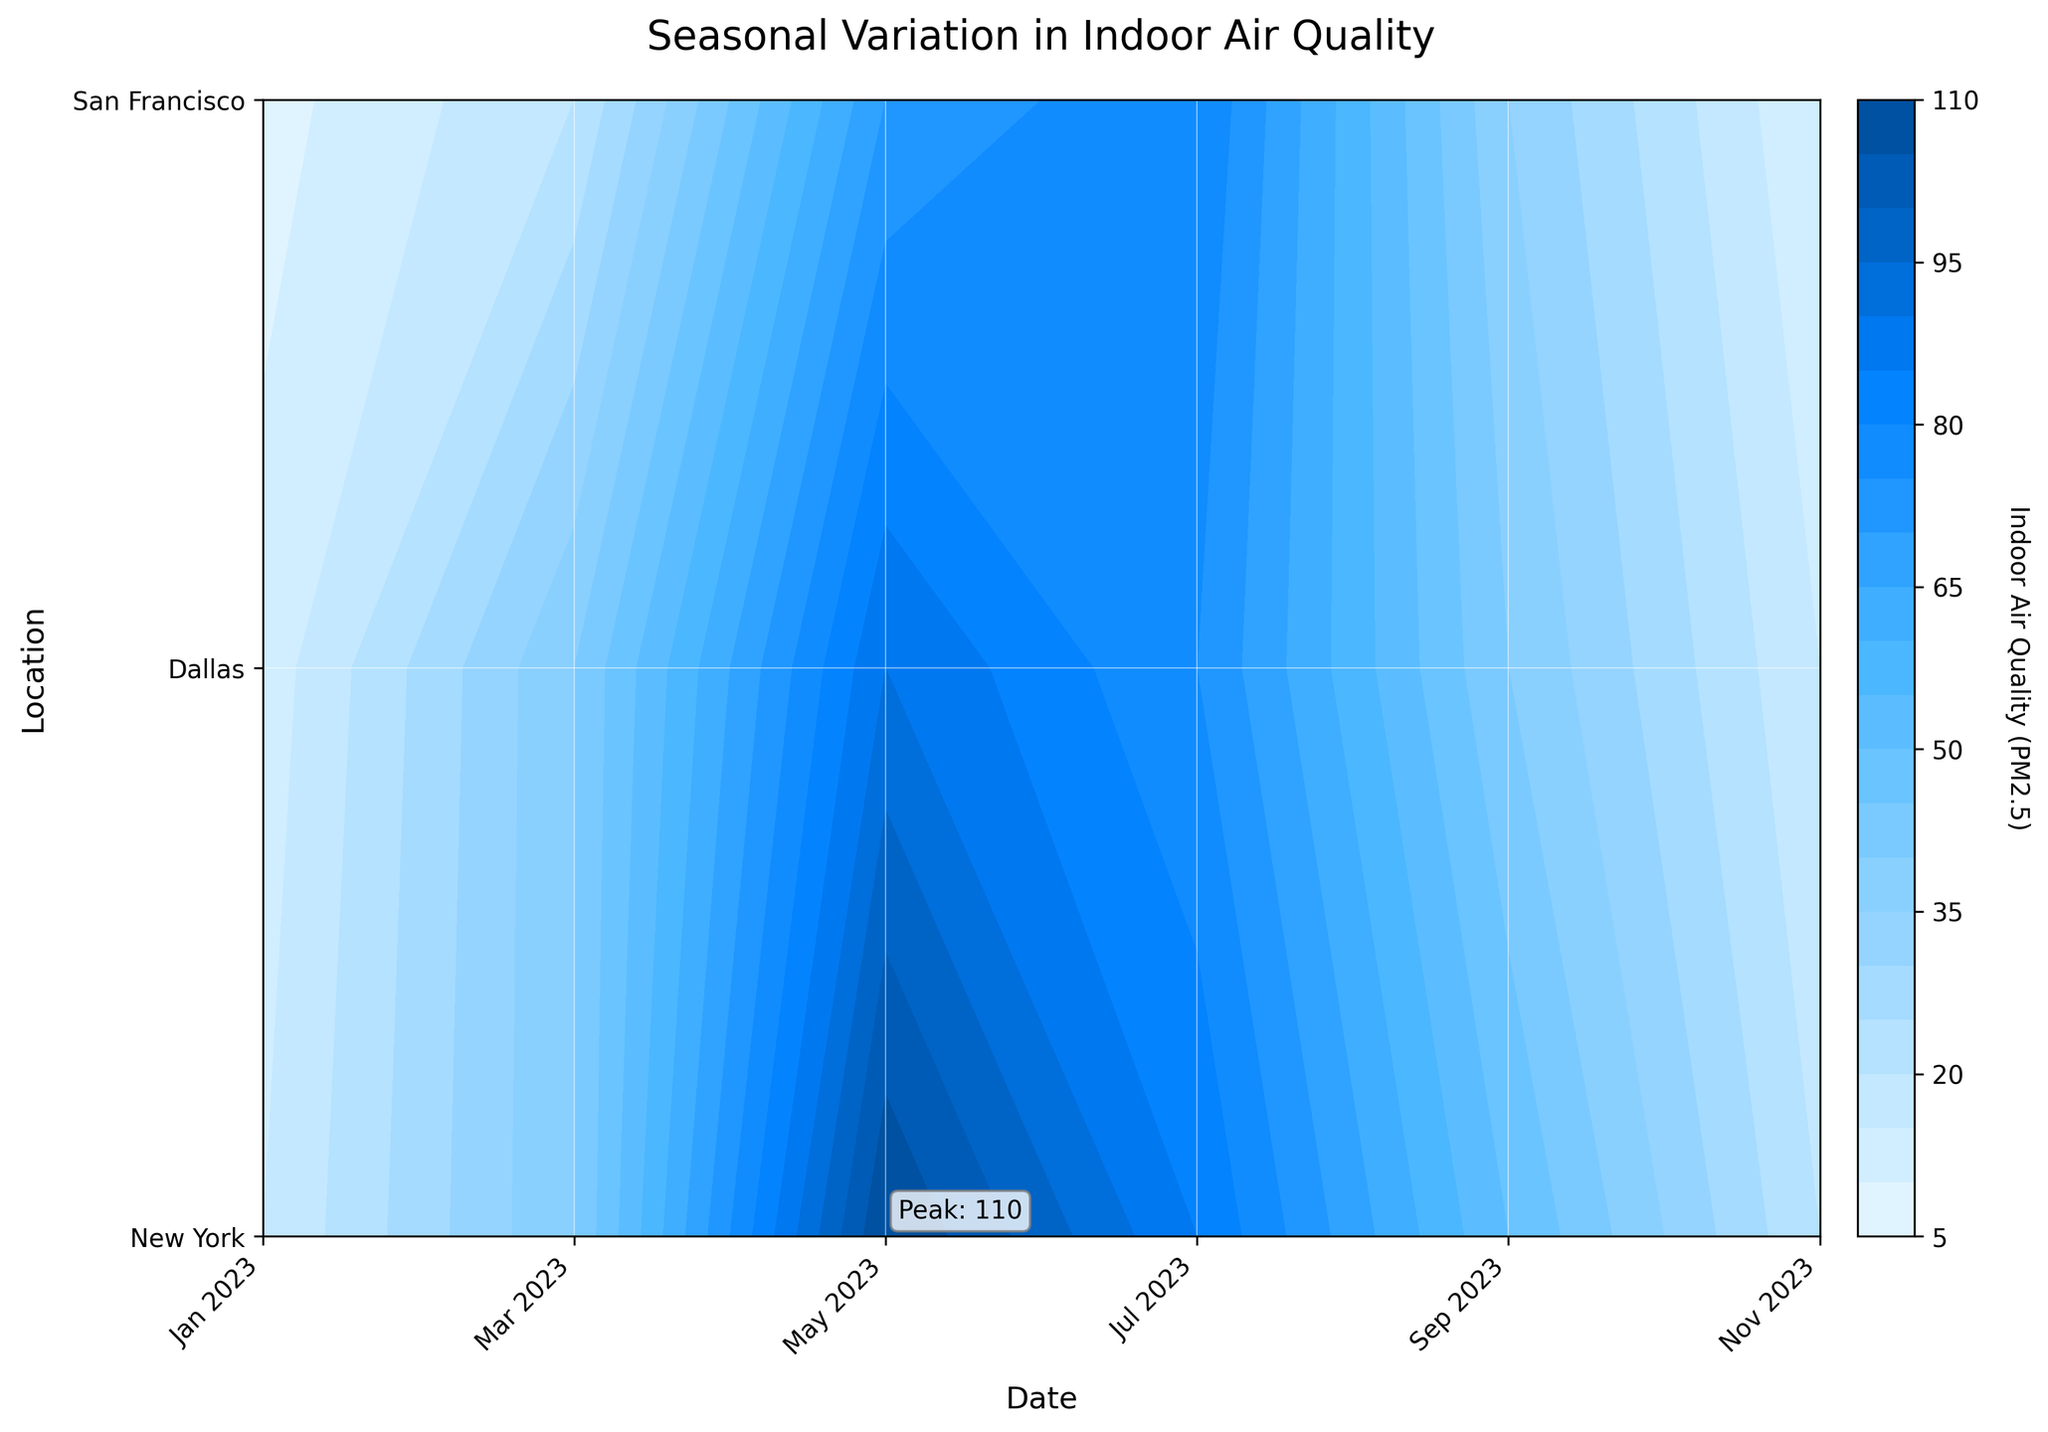What is the title of the plot? The title is usually placed at the top of the plot. In this case, it's written in the figure.
Answer: Seasonal Variation in Indoor Air Quality Which month shows the peak indoor air quality (PM2.5) values? The figure annotates the peak value with the word "Peak". By looking at this annotation, the peak value occurs in May.
Answer: May How does the indoor air quality (PM2.5) in Dallas change from January to July? From January to July in Dallas, the indoor air quality (PM2.5) can be traced from the left to the right across the y-axis label "Dallas" and observing the contour levels: it increases from 15 in January, 40 in March, 110 in May, and reaching 85 in July.
Answer: It increases from January to May, then slightly decreases by July Which location exhibits the highest indoor air quality (PM2.5) in September? In September, by following the x-axis label representing September, San Francisco shows the lowest indoor air quality value (35), compared to New York (40) and Dallas (50).
Answer: Dallas Is the indoor air quality (PM2.5) worse during the summer or winter months in New York? By comparing contour levels across seasons in New York: summer months (July, with a value of 75) show higher values than winter months (January, with a value of 12) indicating worse air quality during summer.
Answer: Summer Compare indoor air quality (PM2.5) levels between New York and San Francisco in March. Which city has better air quality? Trace the March data vertically for both cities, touching the y-axis labels. New York has a level of 40, and San Francisco has a level of 20.
Answer: San Francisco During which month is indoor air quality (PM2.5) in New York the worst? Follow the New York row and identify the month with the highest contour level. May has the highest indoor air quality value for New York.
Answer: May How do pollen levels correlate with indoor air quality (PM2.5)? Higher pollen levels in the data typically correspond to higher indoor air quality values at each time point; for example, May has high pollen levels (150 for New York) and similarly high indoor air quality levels (90 for New York).
Answer: Positive correlation Which month has the lowest indoor air quality (PM2.5) in San Francisco? Looking at the rows belonging to San Francisco, January exhibits the lowest contour level, indicating the lowest indoor air quality value.
Answer: January 